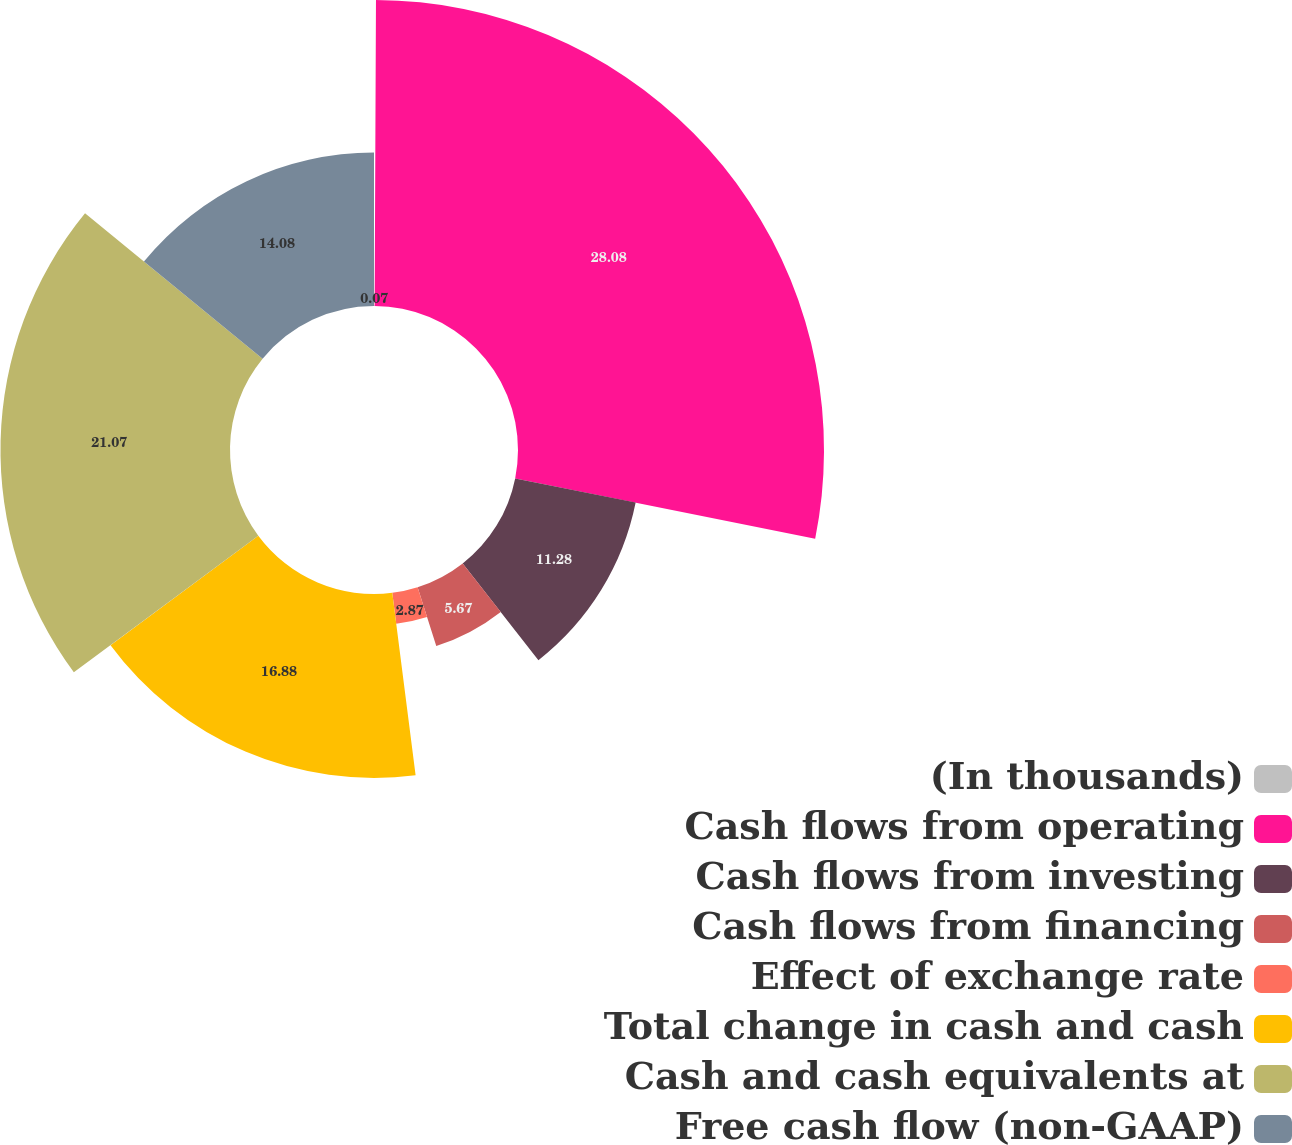Convert chart. <chart><loc_0><loc_0><loc_500><loc_500><pie_chart><fcel>(In thousands)<fcel>Cash flows from operating<fcel>Cash flows from investing<fcel>Cash flows from financing<fcel>Effect of exchange rate<fcel>Total change in cash and cash<fcel>Cash and cash equivalents at<fcel>Free cash flow (non-GAAP)<nl><fcel>0.07%<fcel>28.09%<fcel>11.28%<fcel>5.67%<fcel>2.87%<fcel>16.88%<fcel>21.07%<fcel>14.08%<nl></chart> 